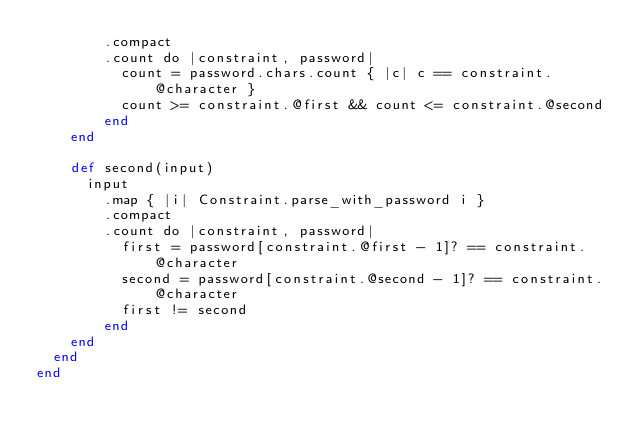<code> <loc_0><loc_0><loc_500><loc_500><_Crystal_>        .compact
        .count do |constraint, password|
          count = password.chars.count { |c| c == constraint.@character }
          count >= constraint.@first && count <= constraint.@second
        end
    end

    def second(input)
      input
        .map { |i| Constraint.parse_with_password i }
        .compact
        .count do |constraint, password|
          first = password[constraint.@first - 1]? == constraint.@character
          second = password[constraint.@second - 1]? == constraint.@character
          first != second
        end
    end
  end
end
</code> 